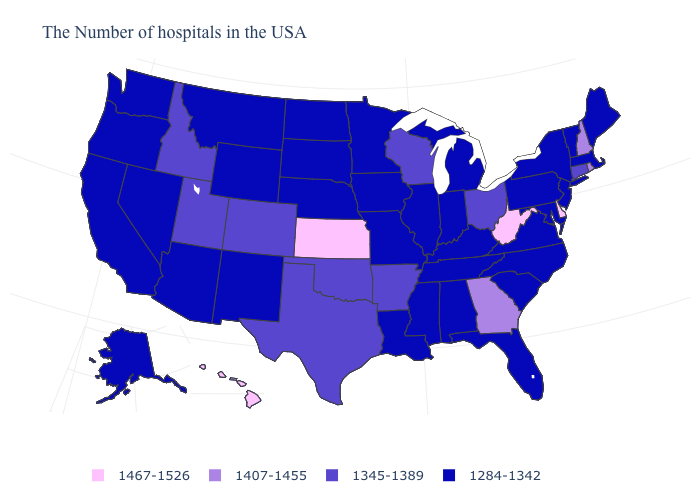What is the value of Ohio?
Keep it brief. 1345-1389. Name the states that have a value in the range 1345-1389?
Be succinct. Connecticut, Ohio, Wisconsin, Arkansas, Oklahoma, Texas, Colorado, Utah, Idaho. Among the states that border Oklahoma , does Texas have the highest value?
Concise answer only. No. What is the value of West Virginia?
Concise answer only. 1467-1526. Does Virginia have the lowest value in the USA?
Answer briefly. Yes. Name the states that have a value in the range 1407-1455?
Keep it brief. Rhode Island, New Hampshire, Georgia. What is the highest value in states that border New Hampshire?
Write a very short answer. 1284-1342. What is the value of New Mexico?
Concise answer only. 1284-1342. Does the map have missing data?
Write a very short answer. No. What is the lowest value in the USA?
Be succinct. 1284-1342. Does West Virginia have the highest value in the South?
Be succinct. Yes. Does the first symbol in the legend represent the smallest category?
Keep it brief. No. Does West Virginia have the lowest value in the South?
Quick response, please. No. Name the states that have a value in the range 1407-1455?
Give a very brief answer. Rhode Island, New Hampshire, Georgia. Does Minnesota have the lowest value in the MidWest?
Give a very brief answer. Yes. 